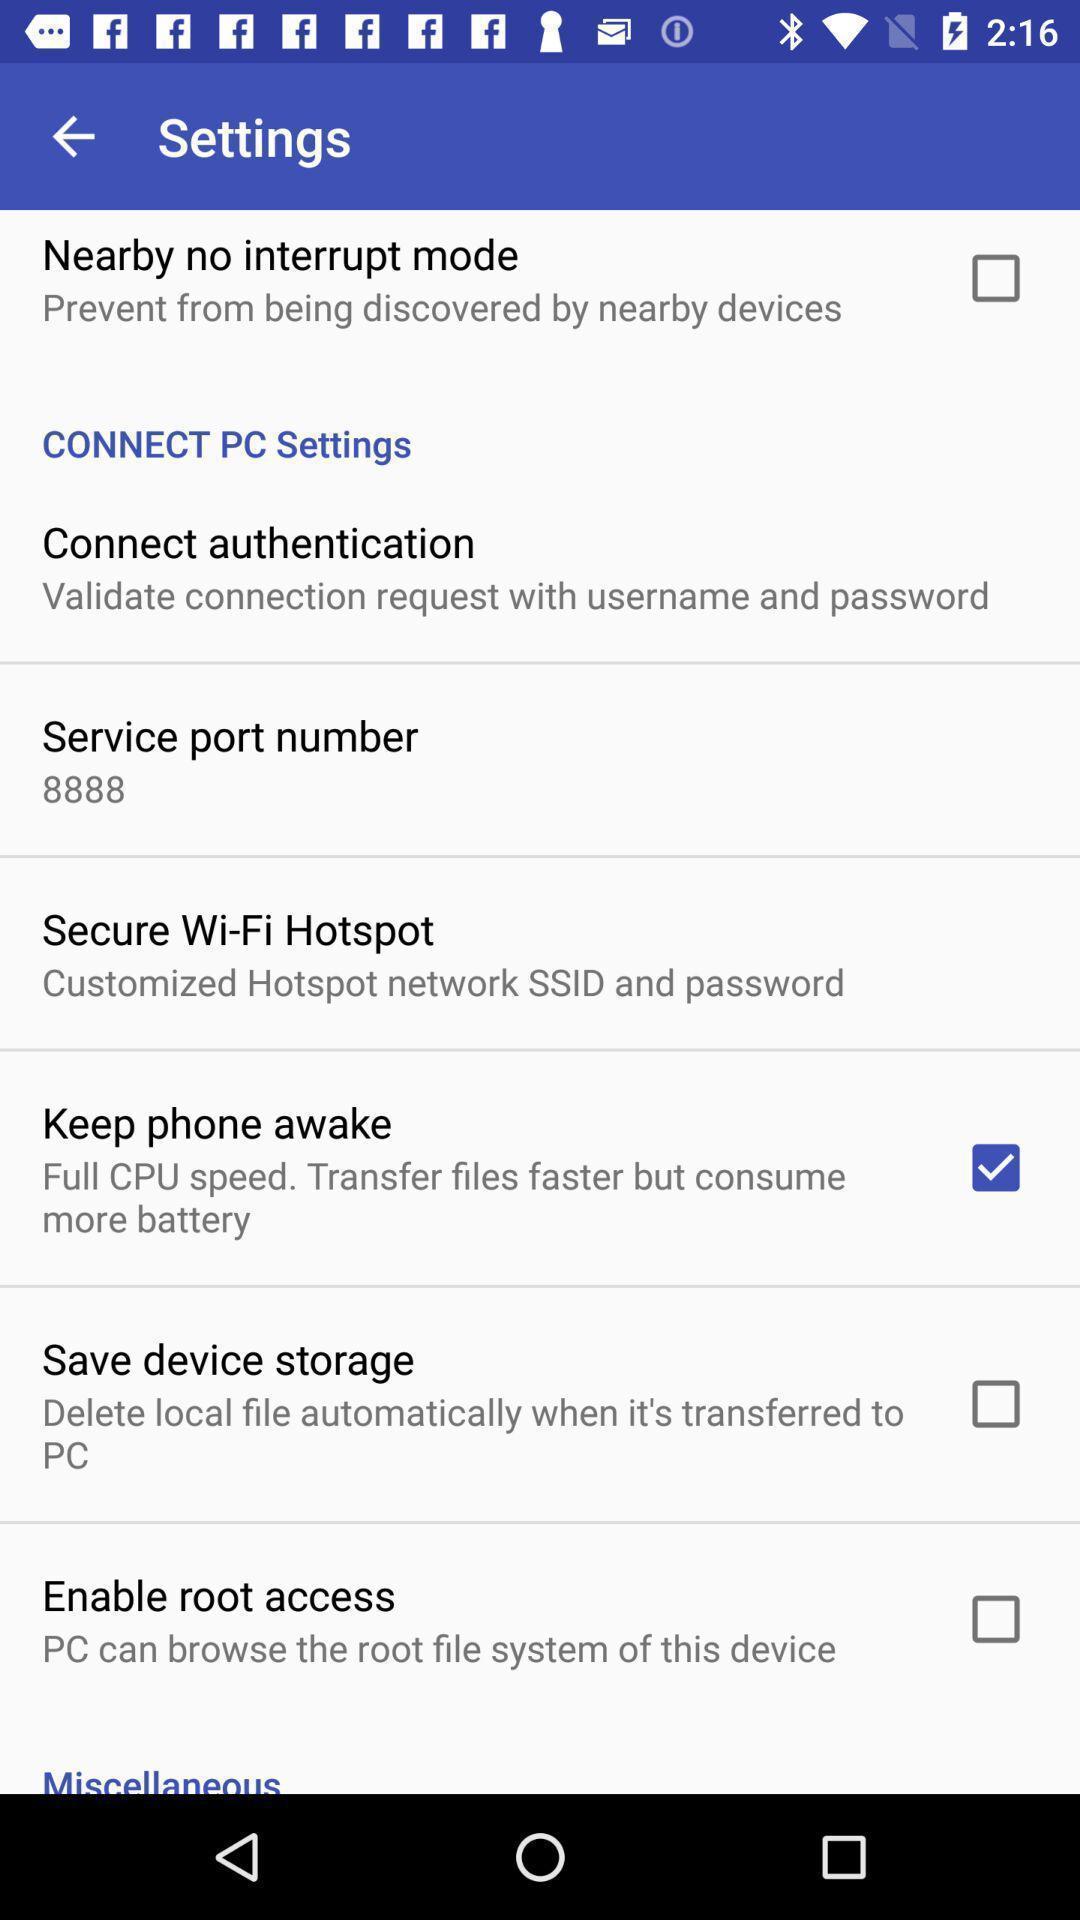Give me a summary of this screen capture. Settings page with few options. 